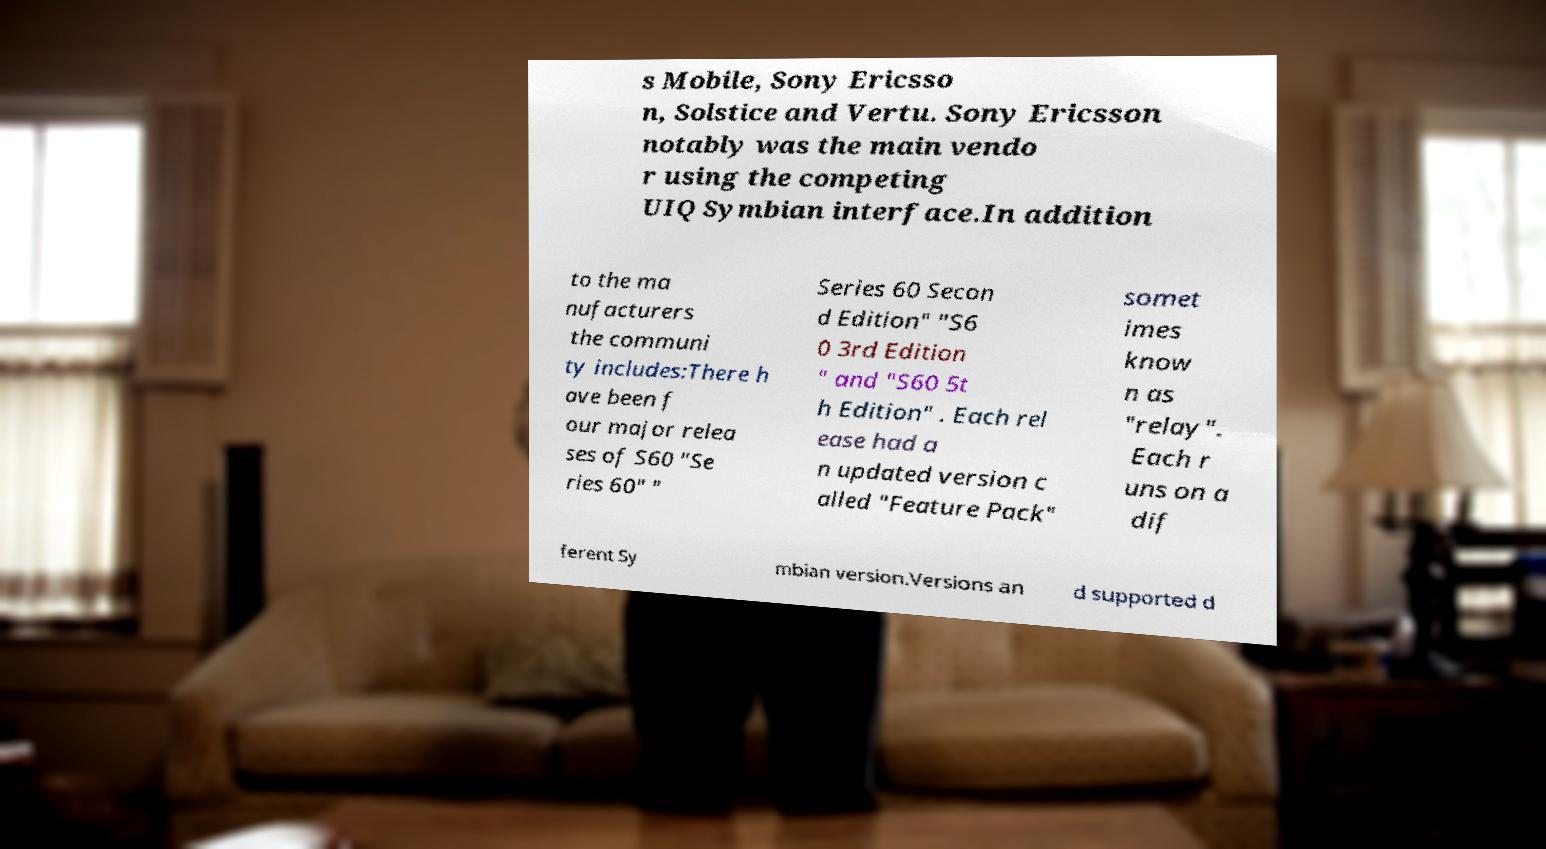There's text embedded in this image that I need extracted. Can you transcribe it verbatim? s Mobile, Sony Ericsso n, Solstice and Vertu. Sony Ericsson notably was the main vendo r using the competing UIQ Symbian interface.In addition to the ma nufacturers the communi ty includes:There h ave been f our major relea ses of S60 "Se ries 60" " Series 60 Secon d Edition" "S6 0 3rd Edition " and "S60 5t h Edition" . Each rel ease had a n updated version c alled "Feature Pack" somet imes know n as "relay". Each r uns on a dif ferent Sy mbian version.Versions an d supported d 